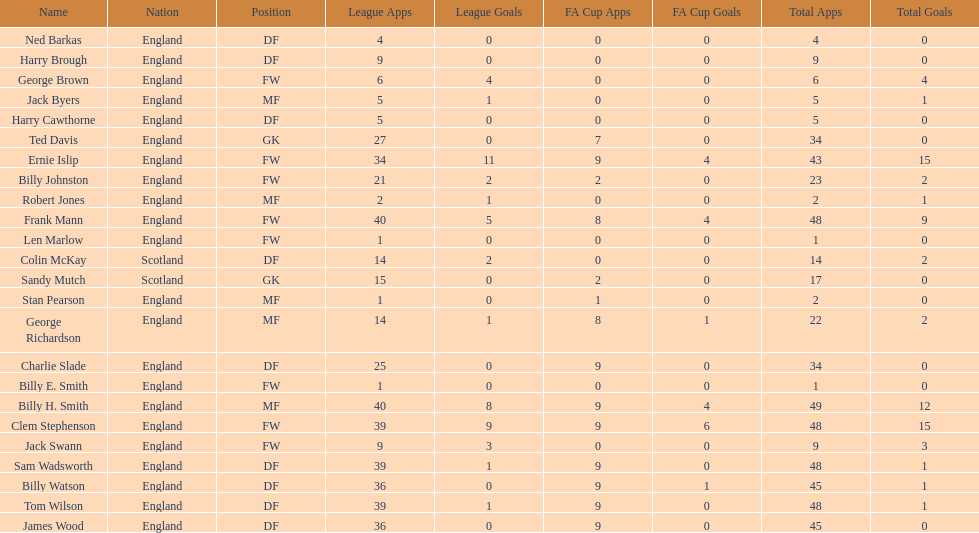What is the typical count of scotland's total apps? 15.5. 